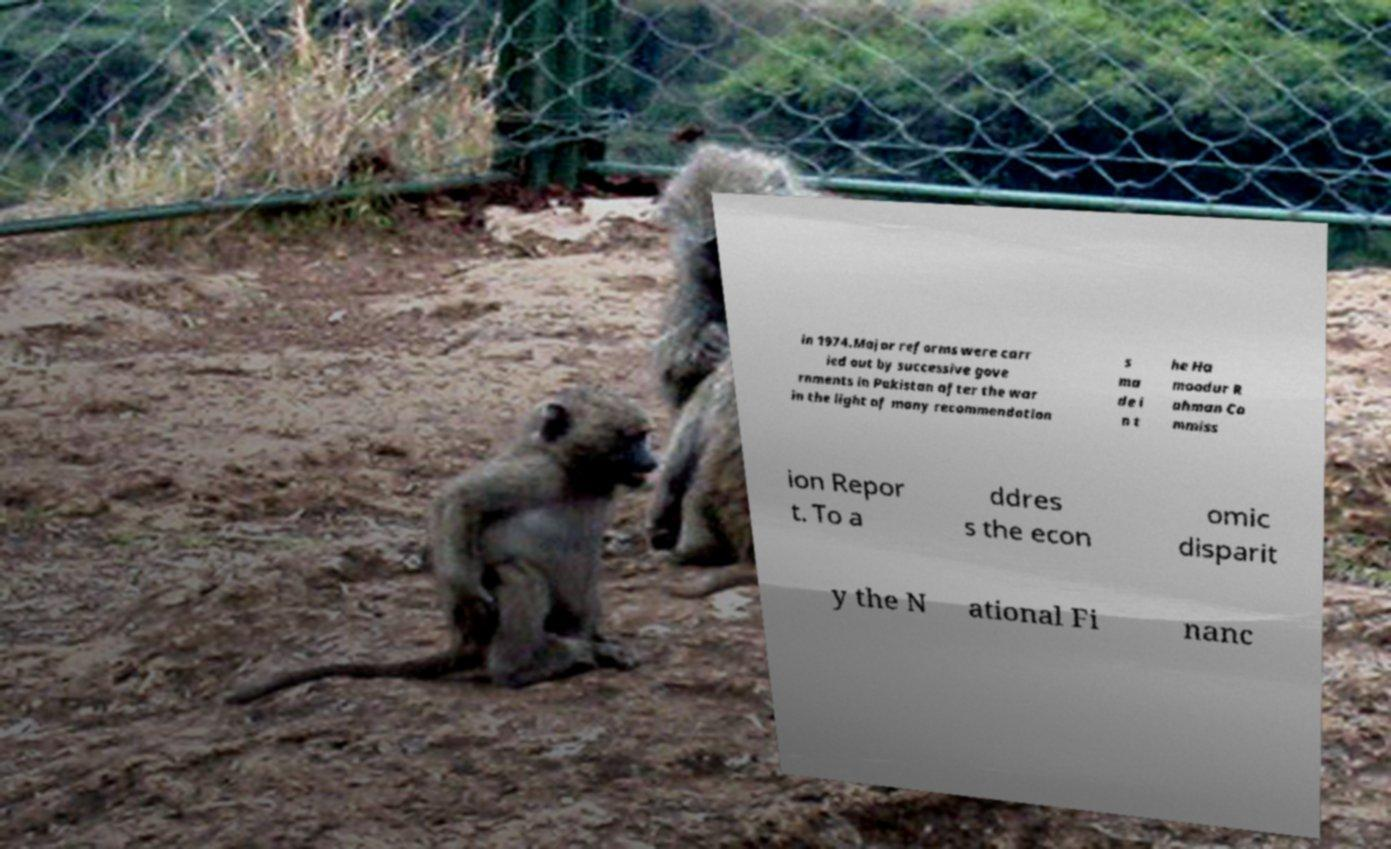Could you assist in decoding the text presented in this image and type it out clearly? in 1974.Major reforms were carr ied out by successive gove rnments in Pakistan after the war in the light of many recommendation s ma de i n t he Ha moodur R ahman Co mmiss ion Repor t. To a ddres s the econ omic disparit y the N ational Fi nanc 